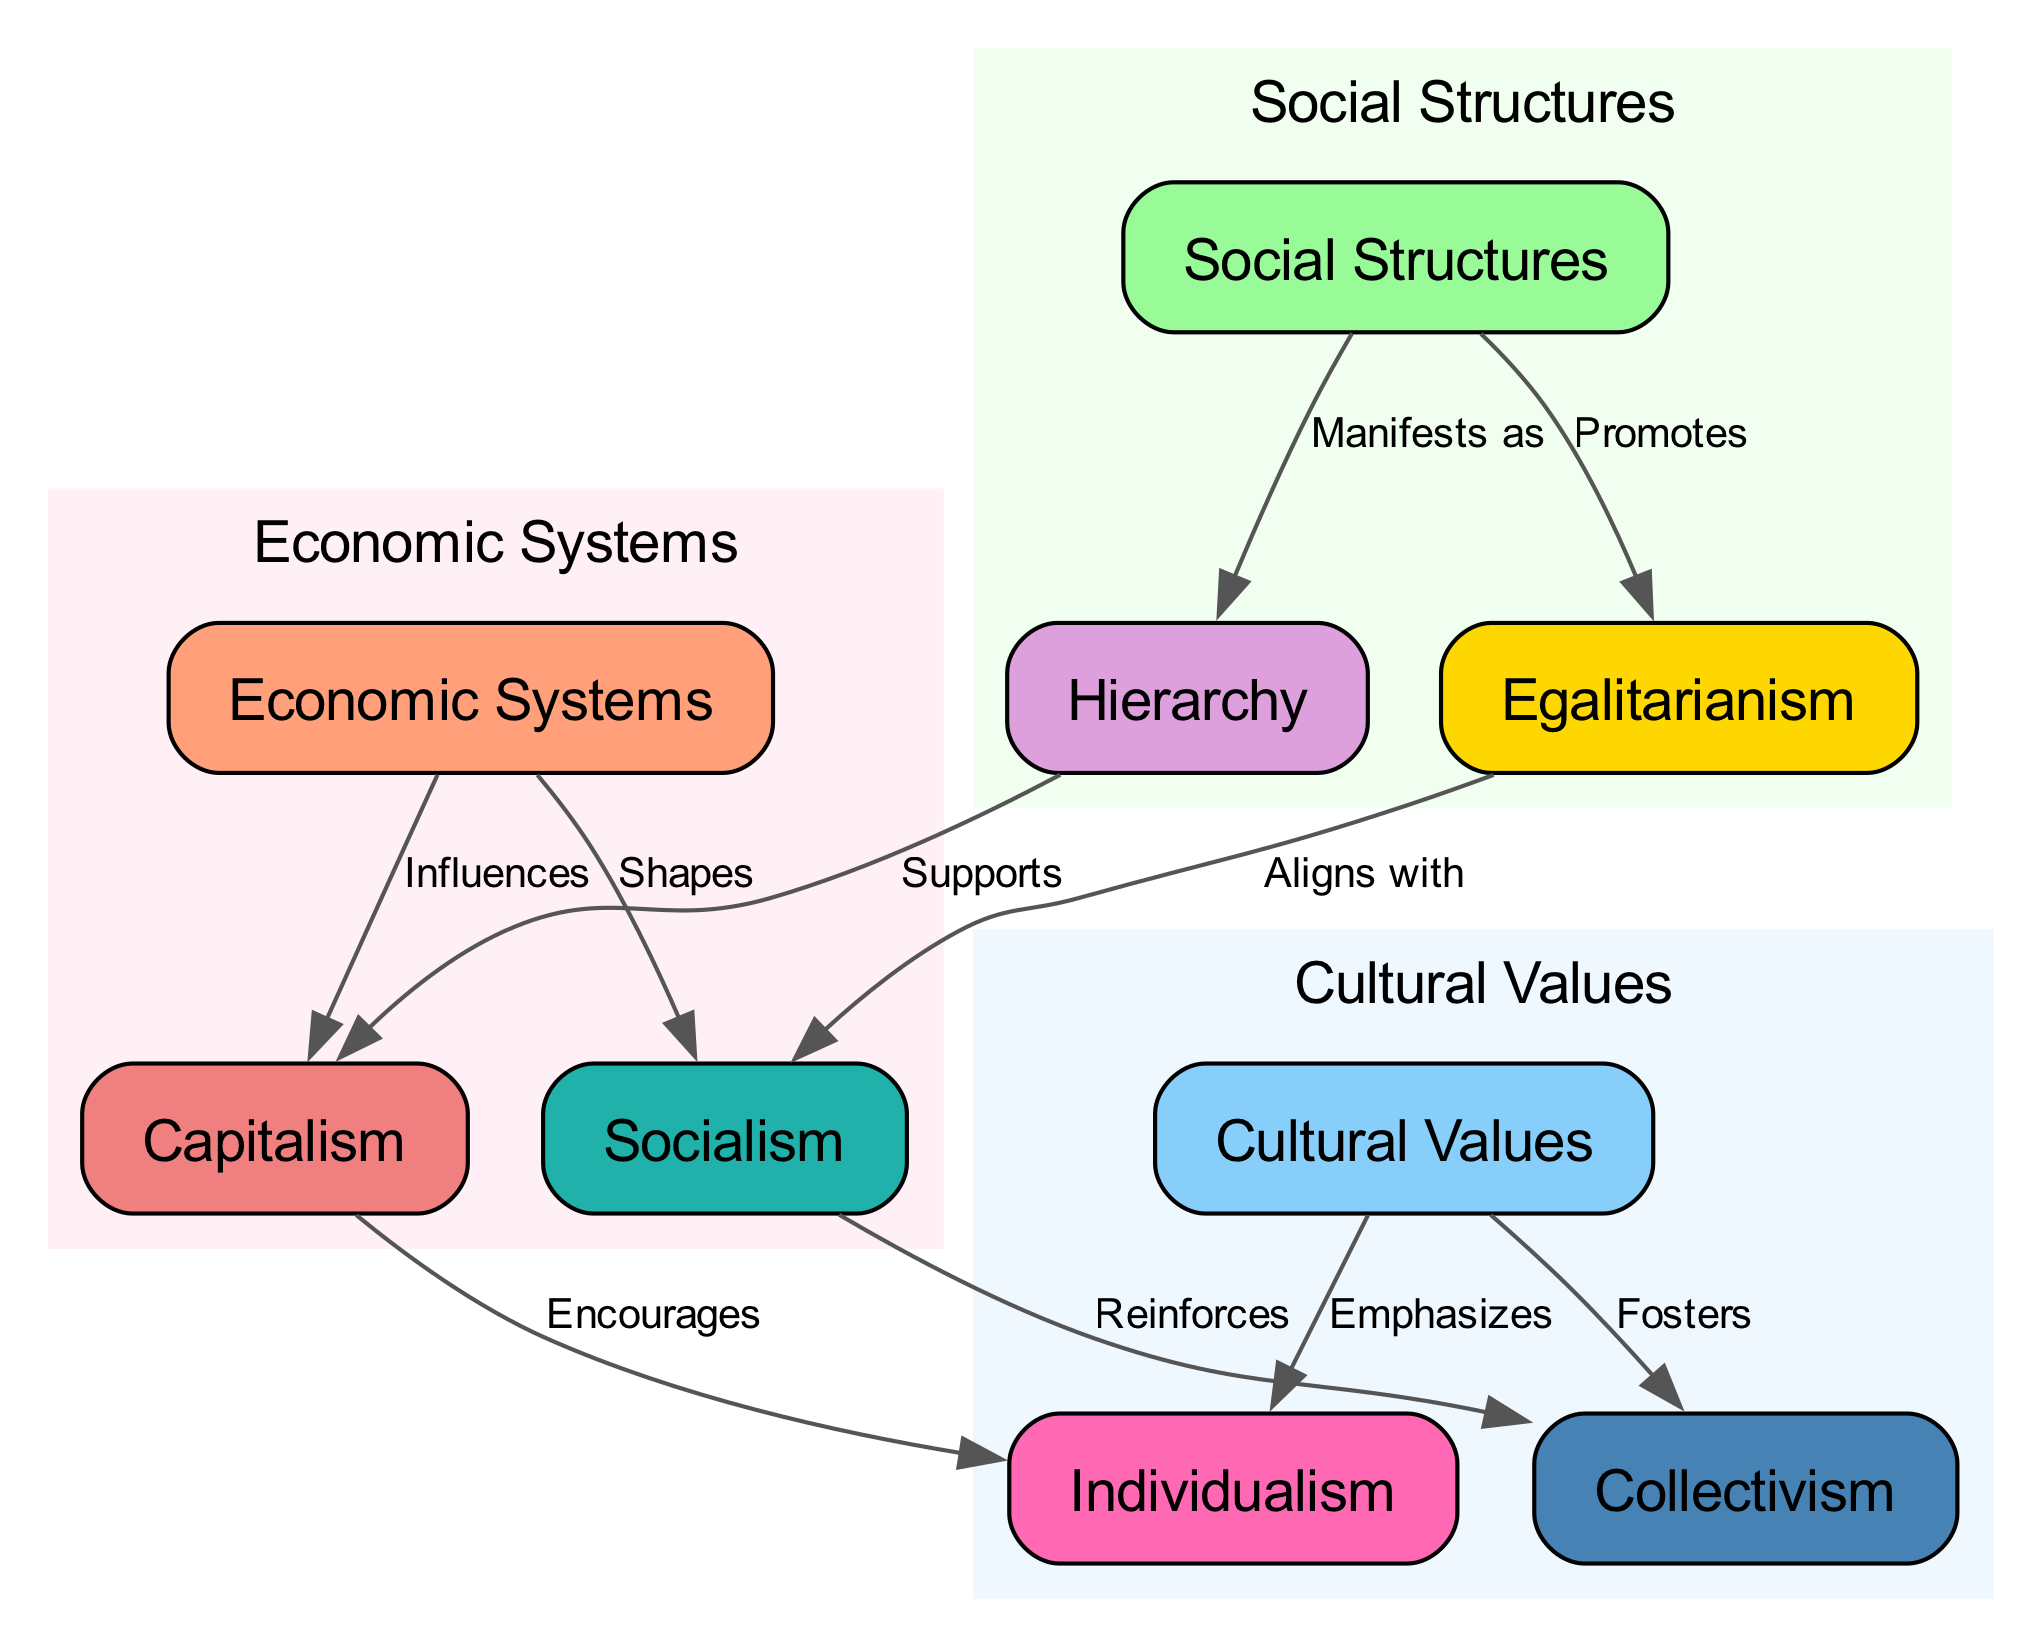What are the three main categories depicted in the diagram? The diagram clearly categorizes the nodes into three main sections: "Economic Systems," "Social Structures," and "Cultural Values." These categories group related concepts together for better understanding of their interrelations.
Answer: Economic Systems, Social Structures, Cultural Values How many nodes are present in the diagram? By counting each unique item listed in the "nodes" section of the data, we find there are a total of 9 distinct nodes that represent different concepts within the diagram.
Answer: 9 What relationship does capitalism have with individualism? According to the diagram, capitalism "Encourages" individualism, indicating a direct influence where capitalist economic systems promote the value of individual autonomy and self-interest.
Answer: Encourages Which social structure aligns with socialism? The diagram specifies that "egalitarianism" "Aligns with" socialism, suggesting that societal structures promoting equality fit well with socialist economic principles.
Answer: Egalitarianism How does socialism influence cultural values? The diagram illustrates that socialism "Reinforces" collectivism, meaning that the values associated with collectivism gain support within societies that operate under socialist economic systems.
Answer: Reinforces How does hierarchy manifest in the context of social structures? The diagram indicates that hierarchy "Manifests as" a type of social structure in societies; thus, it exemplifies the physical arrangement and roles within a given societal framework.
Answer: Manifests as What influences economic systems according to the diagram? The diagram shows that both capitalism and socialism are types of economic systems; the edges indicate that these systems are influenced by social structures, specifically how they branch into hierarchical or egalitarian forms.
Answer: Influences Which cultural value is emphasized by economic systems in the diagram? The diagram states that cultural values like "individualism" are emphasized within capitalist systems, highlighting how cultural attitudes align with economic practices.
Answer: Individualism What does hierarchy support according to the diagram? The diagram illustrates that hierarchy "Supports" capitalism, indicating that structured social arrangements enhance the functioning or acceptance of capitalist economic systems.
Answer: Supports 